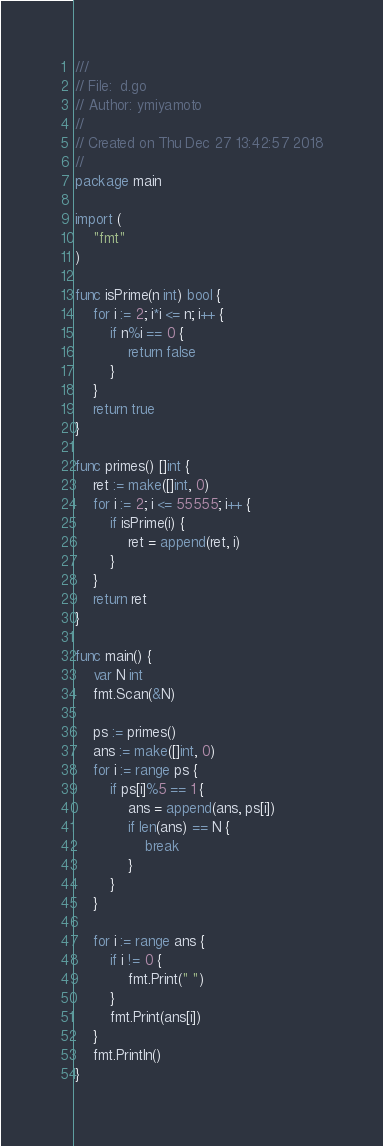Convert code to text. <code><loc_0><loc_0><loc_500><loc_500><_Go_>///
// File:  d.go
// Author: ymiyamoto
//
// Created on Thu Dec 27 13:42:57 2018
//
package main

import (
	"fmt"
)

func isPrime(n int) bool {
	for i := 2; i*i <= n; i++ {
		if n%i == 0 {
			return false
		}
	}
	return true
}

func primes() []int {
	ret := make([]int, 0)
	for i := 2; i <= 55555; i++ {
		if isPrime(i) {
			ret = append(ret, i)
		}
	}
	return ret
}

func main() {
	var N int
	fmt.Scan(&N)

	ps := primes()
	ans := make([]int, 0)
	for i := range ps {
		if ps[i]%5 == 1 {
			ans = append(ans, ps[i])
			if len(ans) == N {
				break
			}
		}
	}

	for i := range ans {
		if i != 0 {
			fmt.Print(" ")
		}
		fmt.Print(ans[i])
	}
	fmt.Println()
}
</code> 